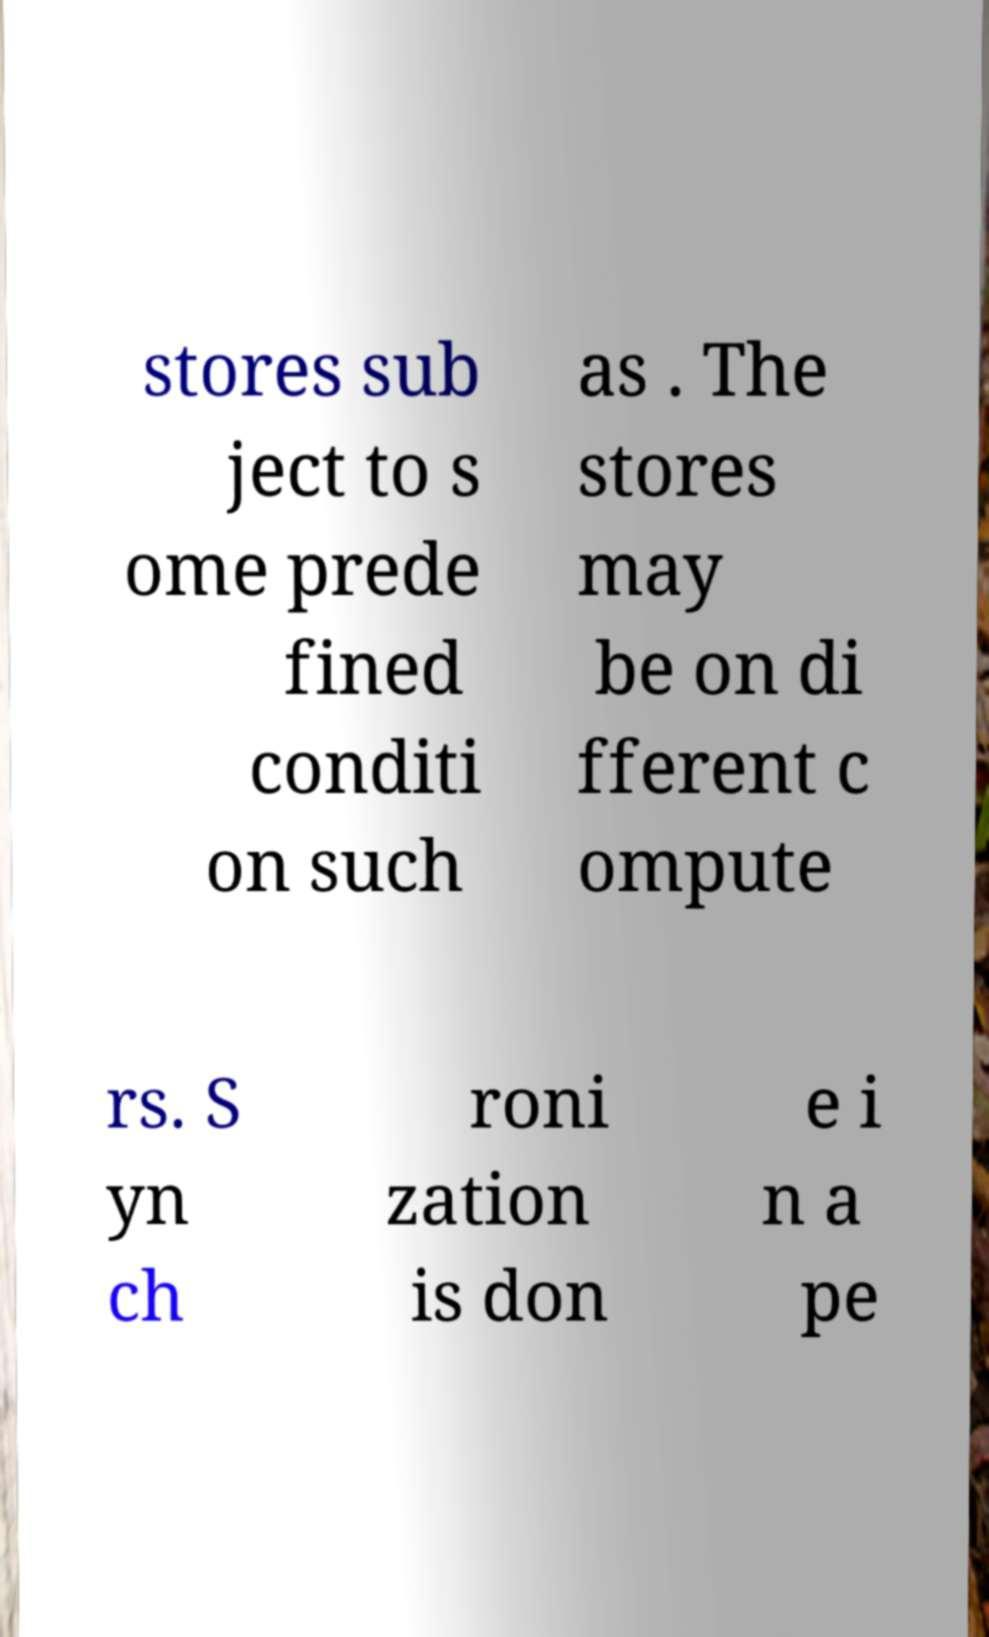What messages or text are displayed in this image? I need them in a readable, typed format. stores sub ject to s ome prede fined conditi on such as . The stores may be on di fferent c ompute rs. S yn ch roni zation is don e i n a pe 